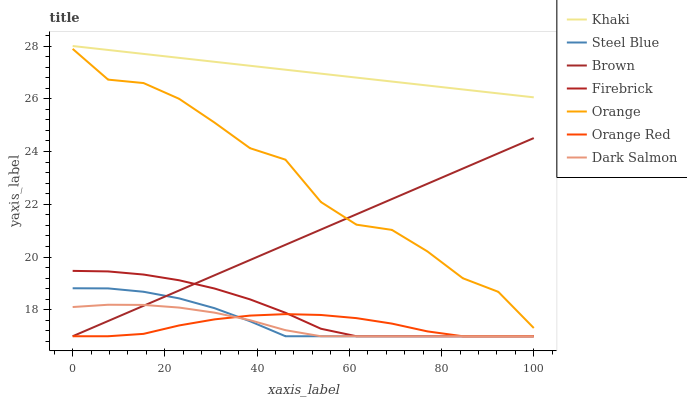Does Orange Red have the minimum area under the curve?
Answer yes or no. Yes. Does Khaki have the maximum area under the curve?
Answer yes or no. Yes. Does Firebrick have the minimum area under the curve?
Answer yes or no. No. Does Firebrick have the maximum area under the curve?
Answer yes or no. No. Is Brown the smoothest?
Answer yes or no. Yes. Is Orange the roughest?
Answer yes or no. Yes. Is Khaki the smoothest?
Answer yes or no. No. Is Khaki the roughest?
Answer yes or no. No. Does Brown have the lowest value?
Answer yes or no. Yes. Does Khaki have the lowest value?
Answer yes or no. No. Does Khaki have the highest value?
Answer yes or no. Yes. Does Firebrick have the highest value?
Answer yes or no. No. Is Orange Red less than Khaki?
Answer yes or no. Yes. Is Khaki greater than Dark Salmon?
Answer yes or no. Yes. Does Brown intersect Orange?
Answer yes or no. Yes. Is Brown less than Orange?
Answer yes or no. No. Is Brown greater than Orange?
Answer yes or no. No. Does Orange Red intersect Khaki?
Answer yes or no. No. 